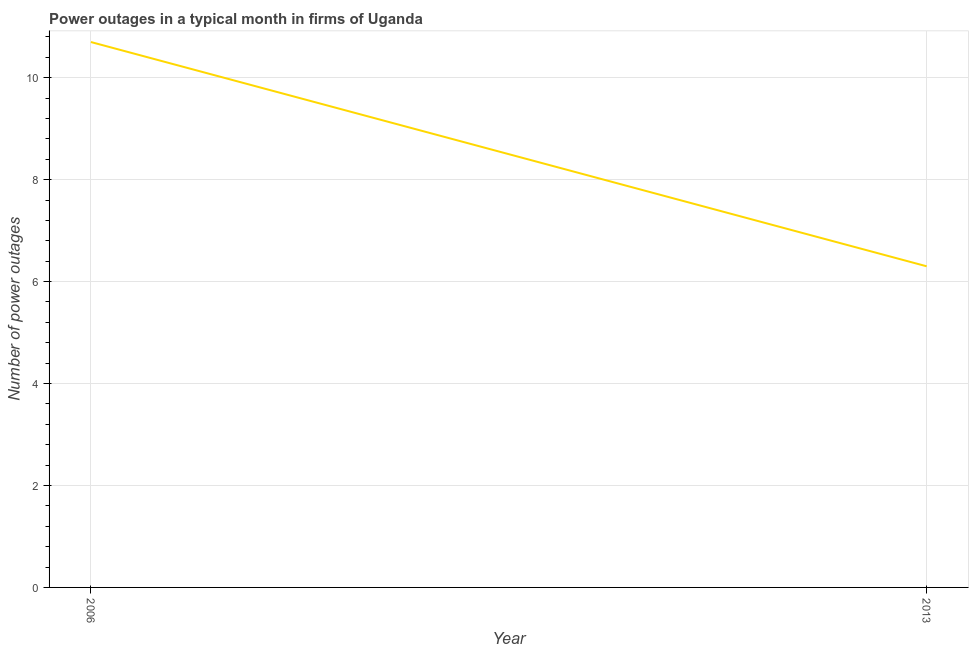What is the number of power outages in 2006?
Provide a succinct answer. 10.7. Across all years, what is the maximum number of power outages?
Your answer should be very brief. 10.7. Across all years, what is the minimum number of power outages?
Your answer should be compact. 6.3. In which year was the number of power outages minimum?
Your response must be concise. 2013. What is the difference between the number of power outages in 2006 and 2013?
Provide a succinct answer. 4.4. What is the average number of power outages per year?
Give a very brief answer. 8.5. What is the median number of power outages?
Provide a short and direct response. 8.5. In how many years, is the number of power outages greater than 7.2 ?
Provide a short and direct response. 1. Do a majority of the years between 2013 and 2006 (inclusive) have number of power outages greater than 0.8 ?
Your answer should be very brief. No. What is the ratio of the number of power outages in 2006 to that in 2013?
Give a very brief answer. 1.7. In how many years, is the number of power outages greater than the average number of power outages taken over all years?
Make the answer very short. 1. Does the number of power outages monotonically increase over the years?
Your response must be concise. No. How many lines are there?
Offer a very short reply. 1. How many years are there in the graph?
Give a very brief answer. 2. What is the difference between two consecutive major ticks on the Y-axis?
Provide a short and direct response. 2. Are the values on the major ticks of Y-axis written in scientific E-notation?
Ensure brevity in your answer.  No. What is the title of the graph?
Ensure brevity in your answer.  Power outages in a typical month in firms of Uganda. What is the label or title of the Y-axis?
Keep it short and to the point. Number of power outages. What is the Number of power outages in 2006?
Offer a terse response. 10.7. What is the difference between the Number of power outages in 2006 and 2013?
Make the answer very short. 4.4. What is the ratio of the Number of power outages in 2006 to that in 2013?
Your response must be concise. 1.7. 